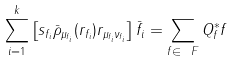<formula> <loc_0><loc_0><loc_500><loc_500>\sum _ { i = 1 } ^ { k } \left [ s _ { f _ { i } } \bar { \rho } _ { \mu _ { f _ { i } } } ( r _ { f _ { i } } ) r _ { \mu _ { f _ { i } } \nu _ { f _ { i } } } \right ] \bar { f } _ { i } = \sum _ { f \in \ F } Q _ { f } ^ { * } f</formula> 